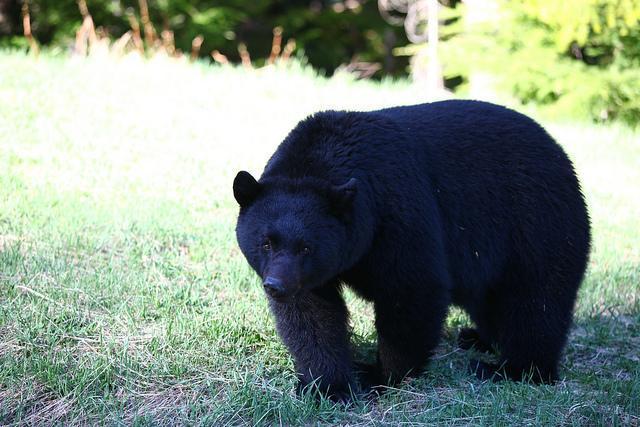How many legs does this animal have?
Give a very brief answer. 4. How many bears are there?
Give a very brief answer. 1. 